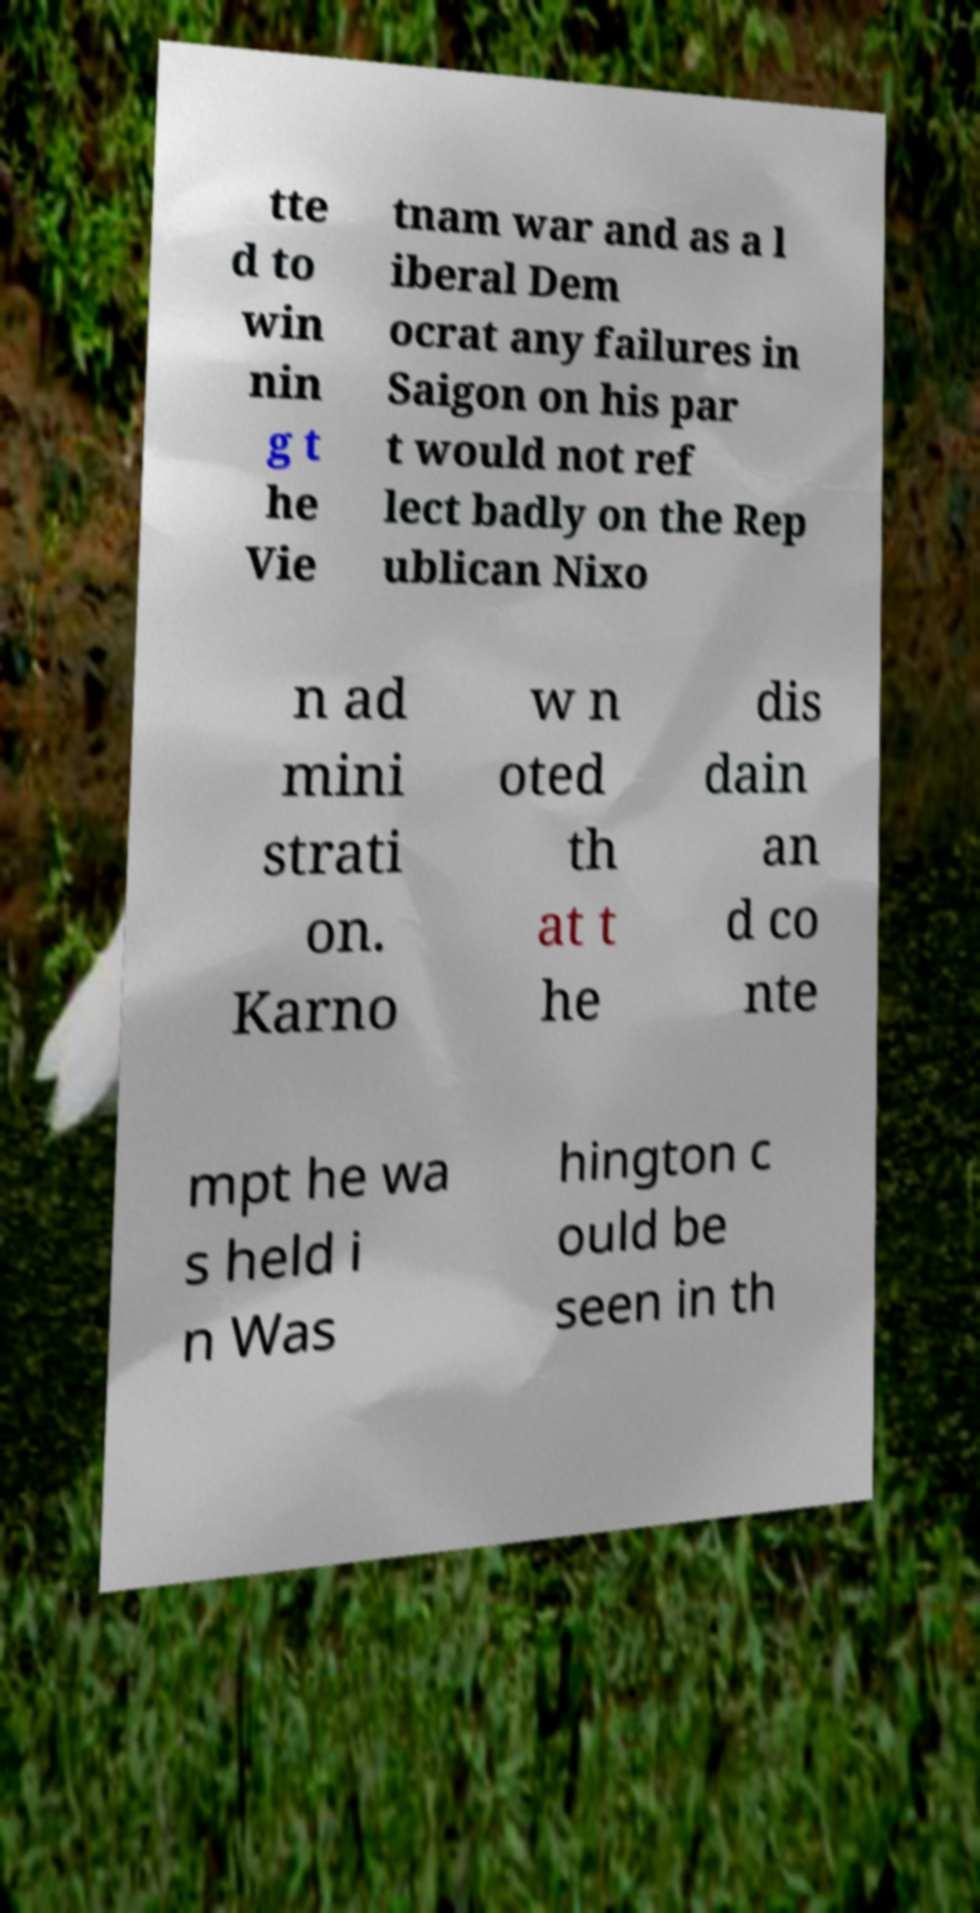Please identify and transcribe the text found in this image. tte d to win nin g t he Vie tnam war and as a l iberal Dem ocrat any failures in Saigon on his par t would not ref lect badly on the Rep ublican Nixo n ad mini strati on. Karno w n oted th at t he dis dain an d co nte mpt he wa s held i n Was hington c ould be seen in th 